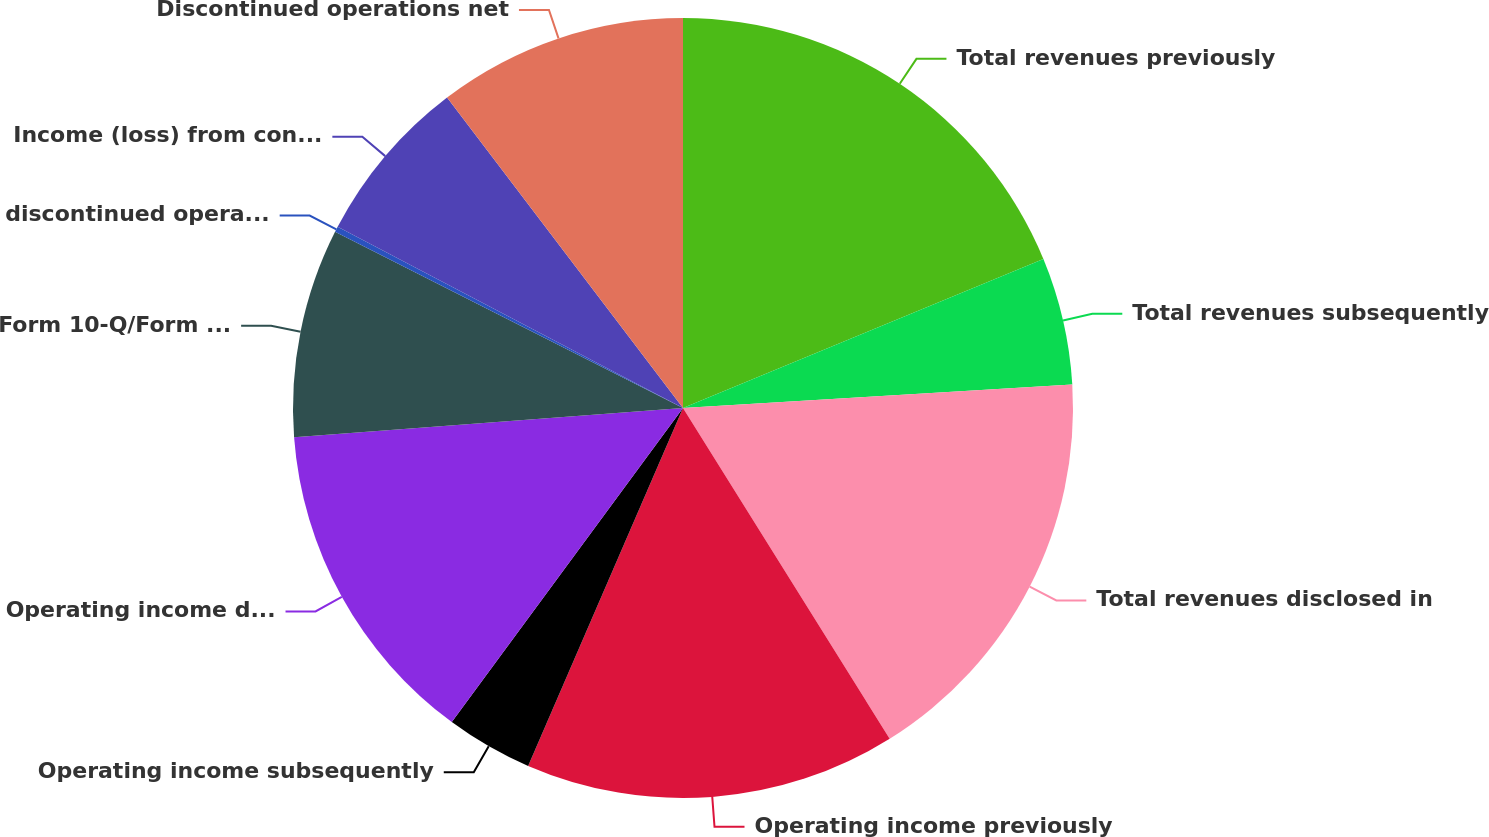<chart> <loc_0><loc_0><loc_500><loc_500><pie_chart><fcel>Total revenues previously<fcel>Total revenues subsequently<fcel>Total revenues disclosed in<fcel>Operating income previously<fcel>Operating income subsequently<fcel>Operating income disclosed in<fcel>Form 10-Q/Form 10-K<fcel>discontinued operations<fcel>Income (loss) from continuing<fcel>Discontinued operations net<nl><fcel>18.76%<fcel>5.28%<fcel>17.07%<fcel>15.39%<fcel>3.6%<fcel>13.71%<fcel>8.65%<fcel>0.23%<fcel>6.97%<fcel>10.34%<nl></chart> 